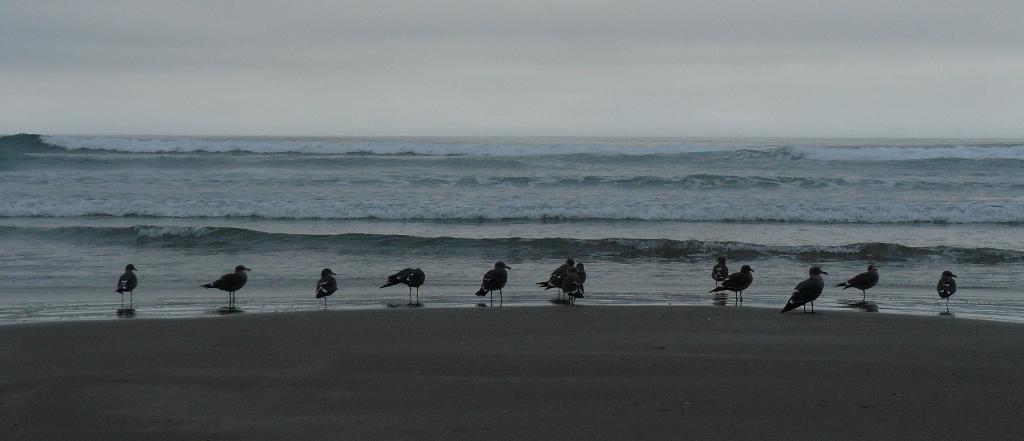How would you summarize this image in a sentence or two? In this image we can see a few birds, also we can see the sea, and the sky. 